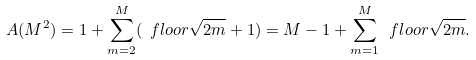Convert formula to latex. <formula><loc_0><loc_0><loc_500><loc_500>A ( M ^ { 2 } ) = 1 + \sum _ { m = 2 } ^ { M } ( \ f l o o r { \sqrt { 2 m } } + 1 ) = M - 1 + \sum _ { m = 1 } ^ { M } \ f l o o r { \sqrt { 2 m } } .</formula> 